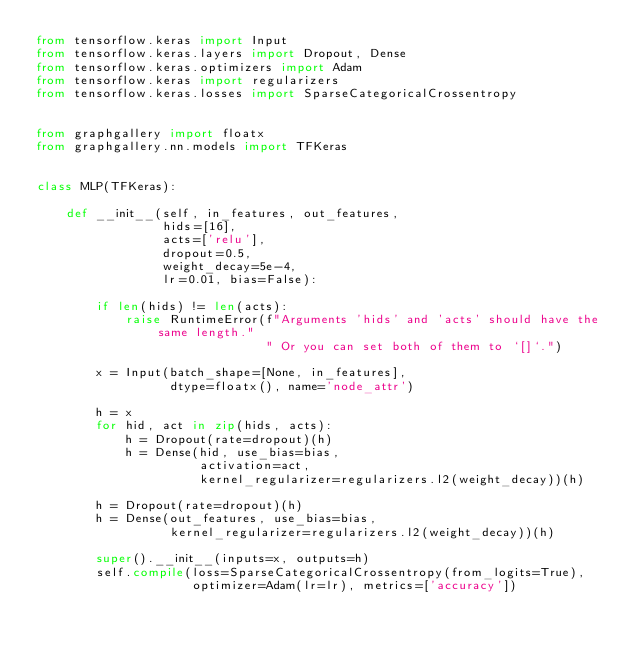Convert code to text. <code><loc_0><loc_0><loc_500><loc_500><_Python_>from tensorflow.keras import Input
from tensorflow.keras.layers import Dropout, Dense
from tensorflow.keras.optimizers import Adam
from tensorflow.keras import regularizers
from tensorflow.keras.losses import SparseCategoricalCrossentropy


from graphgallery import floatx
from graphgallery.nn.models import TFKeras


class MLP(TFKeras):

    def __init__(self, in_features, out_features,
                 hids=[16],
                 acts=['relu'],
                 dropout=0.5,
                 weight_decay=5e-4,
                 lr=0.01, bias=False):

        if len(hids) != len(acts):
            raise RuntimeError(f"Arguments 'hids' and 'acts' should have the same length."
                               " Or you can set both of them to `[]`.")

        x = Input(batch_shape=[None, in_features],
                  dtype=floatx(), name='node_attr')

        h = x
        for hid, act in zip(hids, acts):
            h = Dropout(rate=dropout)(h)
            h = Dense(hid, use_bias=bias,
                      activation=act,
                      kernel_regularizer=regularizers.l2(weight_decay))(h)

        h = Dropout(rate=dropout)(h)
        h = Dense(out_features, use_bias=bias,
                  kernel_regularizer=regularizers.l2(weight_decay))(h)

        super().__init__(inputs=x, outputs=h)
        self.compile(loss=SparseCategoricalCrossentropy(from_logits=True),
                     optimizer=Adam(lr=lr), metrics=['accuracy'])
</code> 